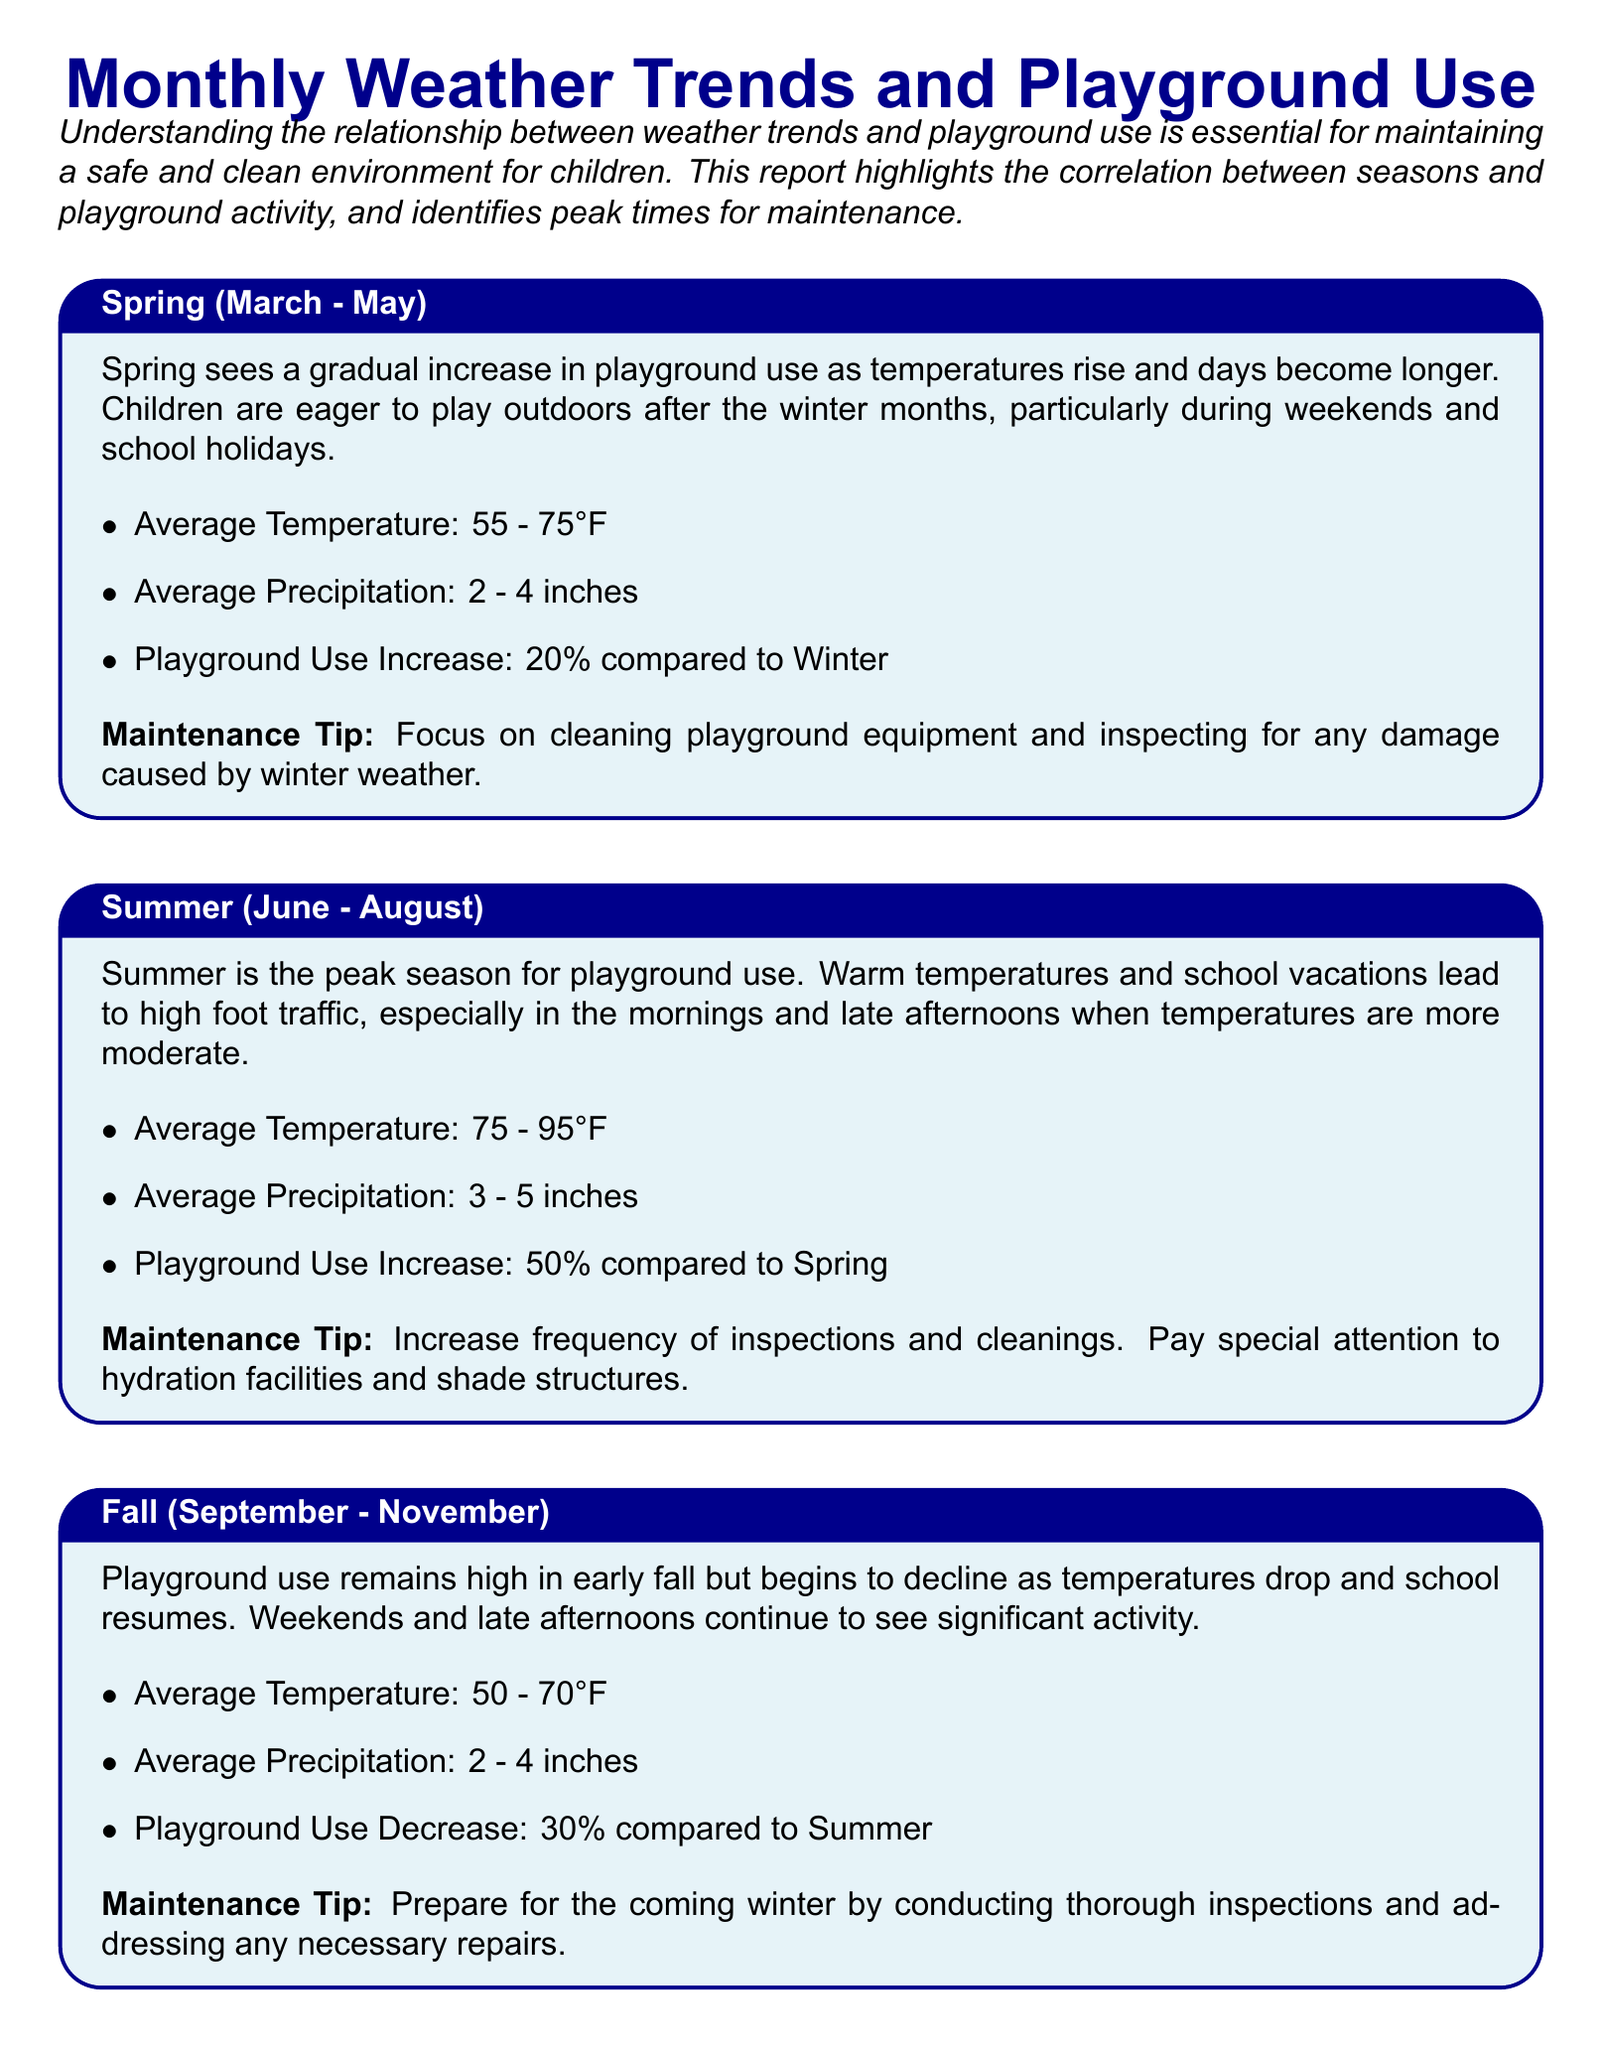What is the average temperature in spring? The average temperature in spring ranges from 55 to 75 degrees Fahrenheit.
Answer: 55 - 75°F What is the playground use increase in spring compared to winter? In spring, playground use increases by 20 percent compared to winter.
Answer: 20% What is the average precipitation in summer? The average precipitation in summer is between 3 and 5 inches.
Answer: 3 - 5 inches What maintenance action is suggested for fall? A thorough inspection and addressing necessary repairs are suggested for fall maintenance.
Answer: Conduct inspections What is the playground use decrease in winter compared to fall? Playground use decreases by 70 percent in winter compared to fall.
Answer: 70% What is the peak season for playground use? Summer is identified as the peak season for playground use.
Answer: Summer How much should the frequency of inspections increase during summer? The document advises increasing the frequency of inspections during summer.
Answer: Increase frequency Which season has the lowest average temperature? Winter has the lowest average temperature compared to other seasons.
Answer: Winter What is a key tip for maintenance during spring? Cleaning playground equipment and inspecting for winter weather damage is a key maintenance tip for spring.
Answer: Cleaning equipment 